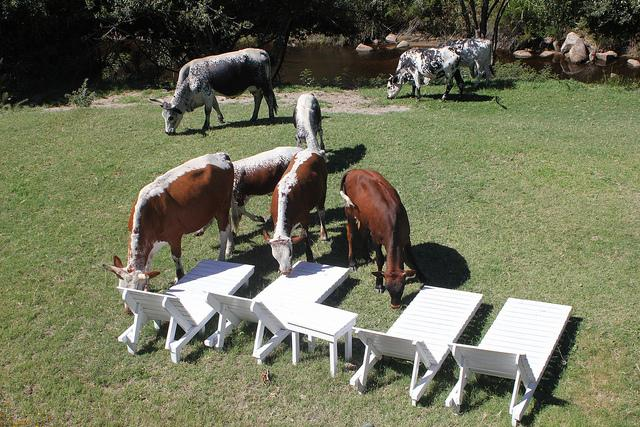What are the animals near? Please explain your reasoning. chairs. The animals are by chairs. 